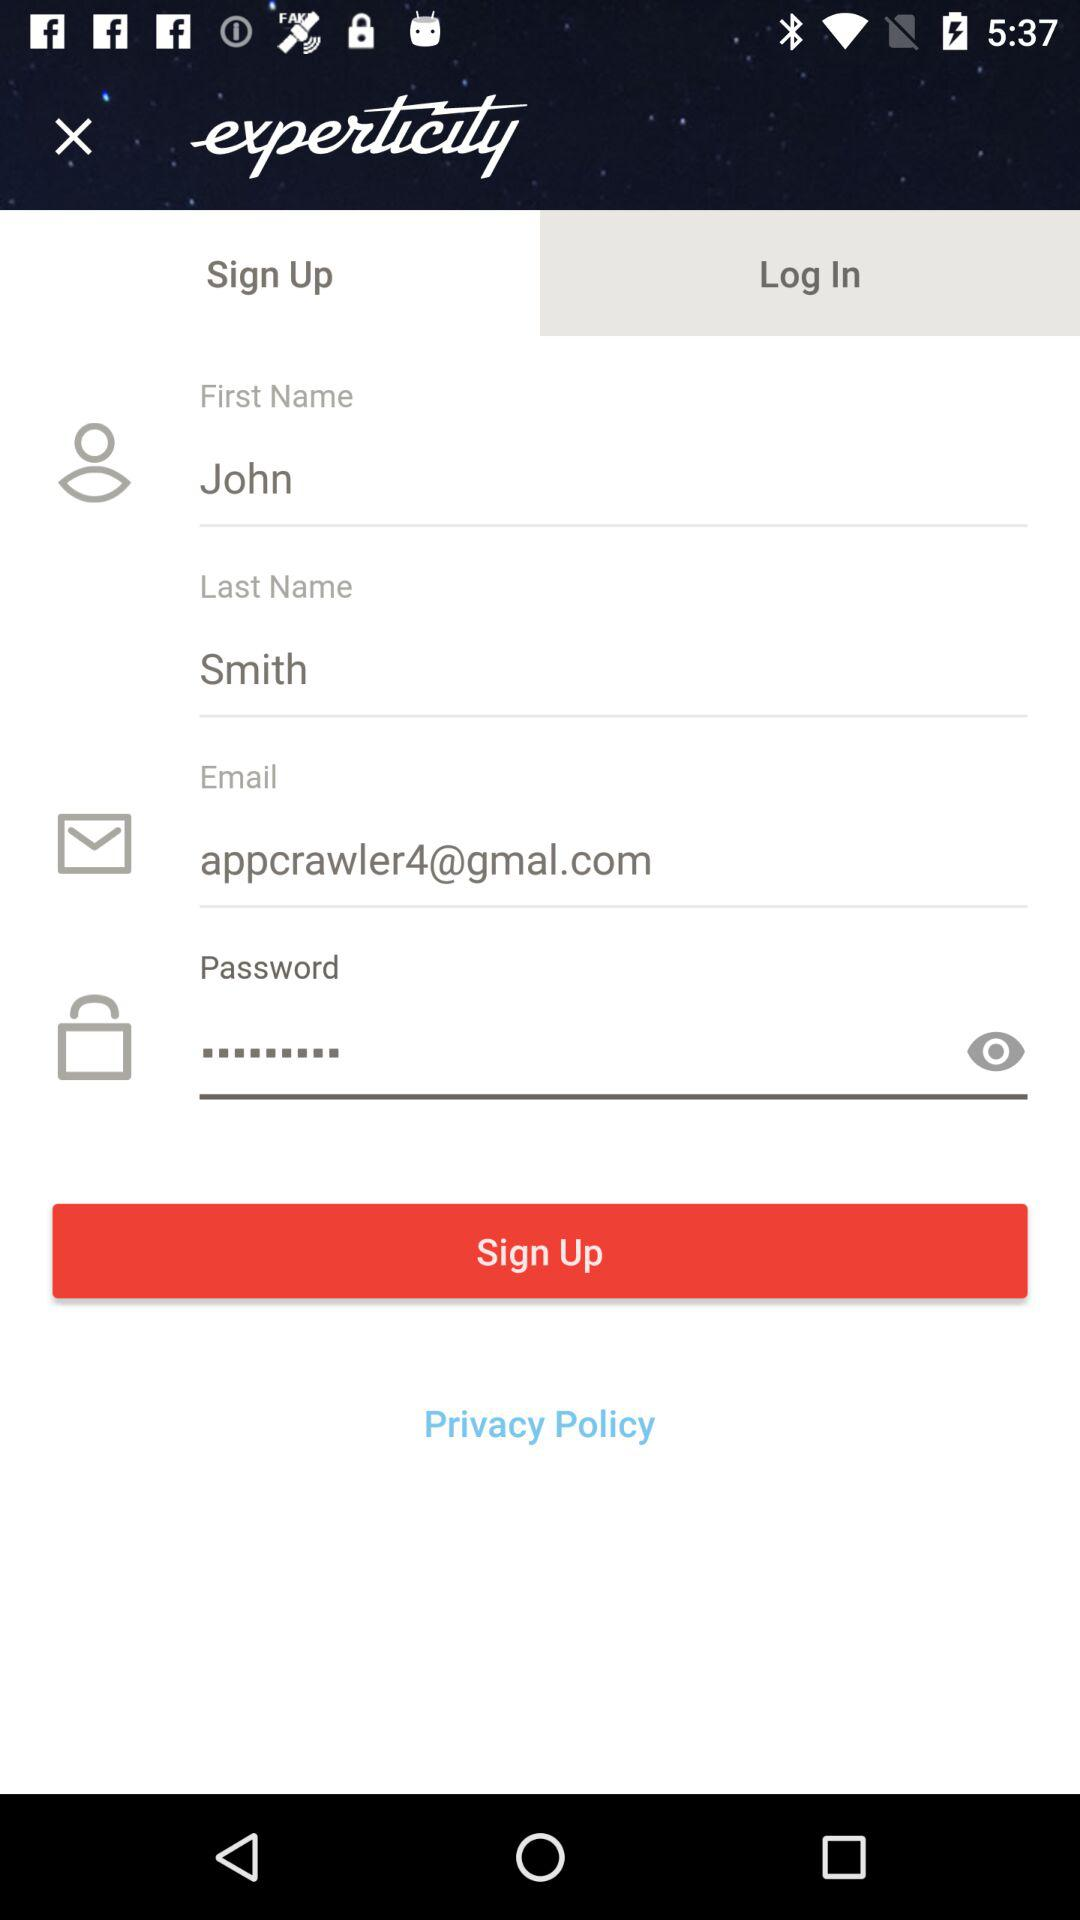Which tab is currently selected? The currently selected tab is "Sign Up". 